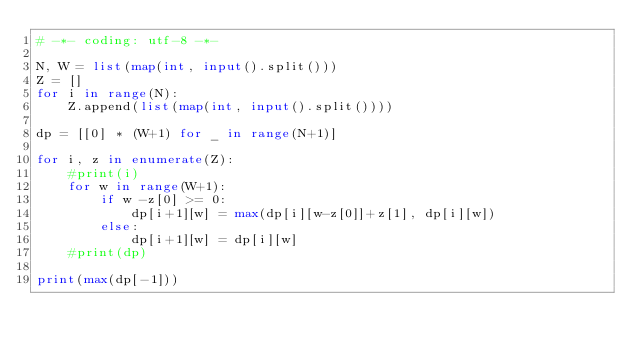<code> <loc_0><loc_0><loc_500><loc_500><_Python_># -*- coding: utf-8 -*-

N, W = list(map(int, input().split()))
Z = []
for i in range(N):
    Z.append(list(map(int, input().split())))

dp = [[0] * (W+1) for _ in range(N+1)]

for i, z in enumerate(Z):
    #print(i)
    for w in range(W+1):
        if w -z[0] >= 0:
            dp[i+1][w] = max(dp[i][w-z[0]]+z[1], dp[i][w])
        else:
            dp[i+1][w] = dp[i][w]
    #print(dp)

print(max(dp[-1]))
</code> 